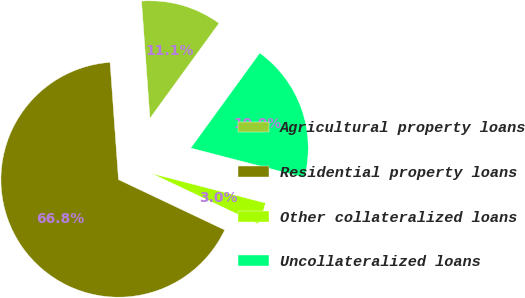Convert chart to OTSL. <chart><loc_0><loc_0><loc_500><loc_500><pie_chart><fcel>Agricultural property loans<fcel>Residential property loans<fcel>Other collateralized loans<fcel>Uncollateralized loans<nl><fcel>11.14%<fcel>66.82%<fcel>3.01%<fcel>19.04%<nl></chart> 